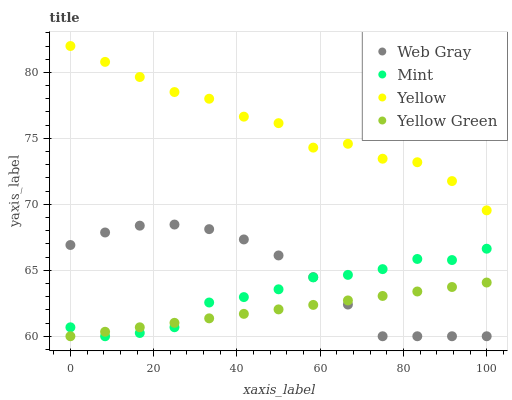Does Yellow Green have the minimum area under the curve?
Answer yes or no. Yes. Does Yellow have the maximum area under the curve?
Answer yes or no. Yes. Does Mint have the minimum area under the curve?
Answer yes or no. No. Does Mint have the maximum area under the curve?
Answer yes or no. No. Is Yellow Green the smoothest?
Answer yes or no. Yes. Is Yellow the roughest?
Answer yes or no. Yes. Is Mint the smoothest?
Answer yes or no. No. Is Mint the roughest?
Answer yes or no. No. Does Web Gray have the lowest value?
Answer yes or no. Yes. Does Yellow have the lowest value?
Answer yes or no. No. Does Yellow have the highest value?
Answer yes or no. Yes. Does Mint have the highest value?
Answer yes or no. No. Is Yellow Green less than Yellow?
Answer yes or no. Yes. Is Yellow greater than Yellow Green?
Answer yes or no. Yes. Does Mint intersect Web Gray?
Answer yes or no. Yes. Is Mint less than Web Gray?
Answer yes or no. No. Is Mint greater than Web Gray?
Answer yes or no. No. Does Yellow Green intersect Yellow?
Answer yes or no. No. 